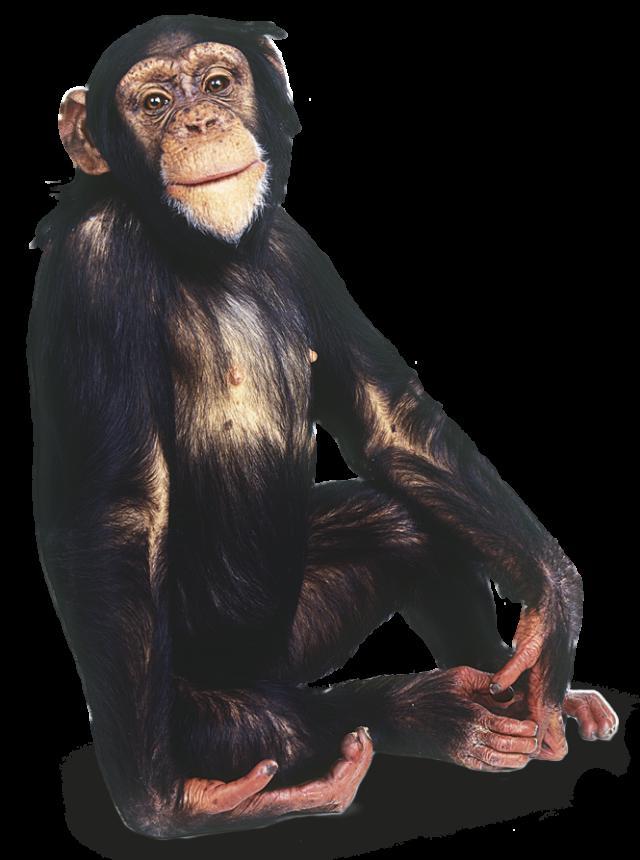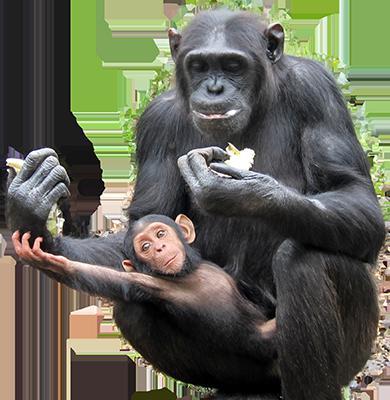The first image is the image on the left, the second image is the image on the right. For the images displayed, is the sentence "A primate is being shown against a black background." factually correct? Answer yes or no. Yes. The first image is the image on the left, the second image is the image on the right. Examine the images to the left and right. Is the description "Each image shows exactly one chimpanzee, with at least one of its hands touching part of its body." accurate? Answer yes or no. No. 